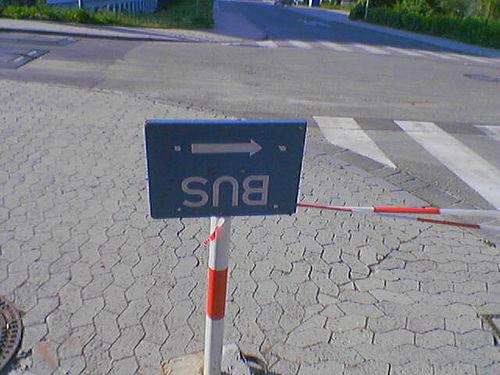Why is the word bus upside down?
Concise answer only. Upside down sign. What are the stripes on the road for?
Quick response, please. Crosswalk. What is the blue thing on the pole called?
Short answer required. Sign. What color is the sign?
Write a very short answer. Blue. 